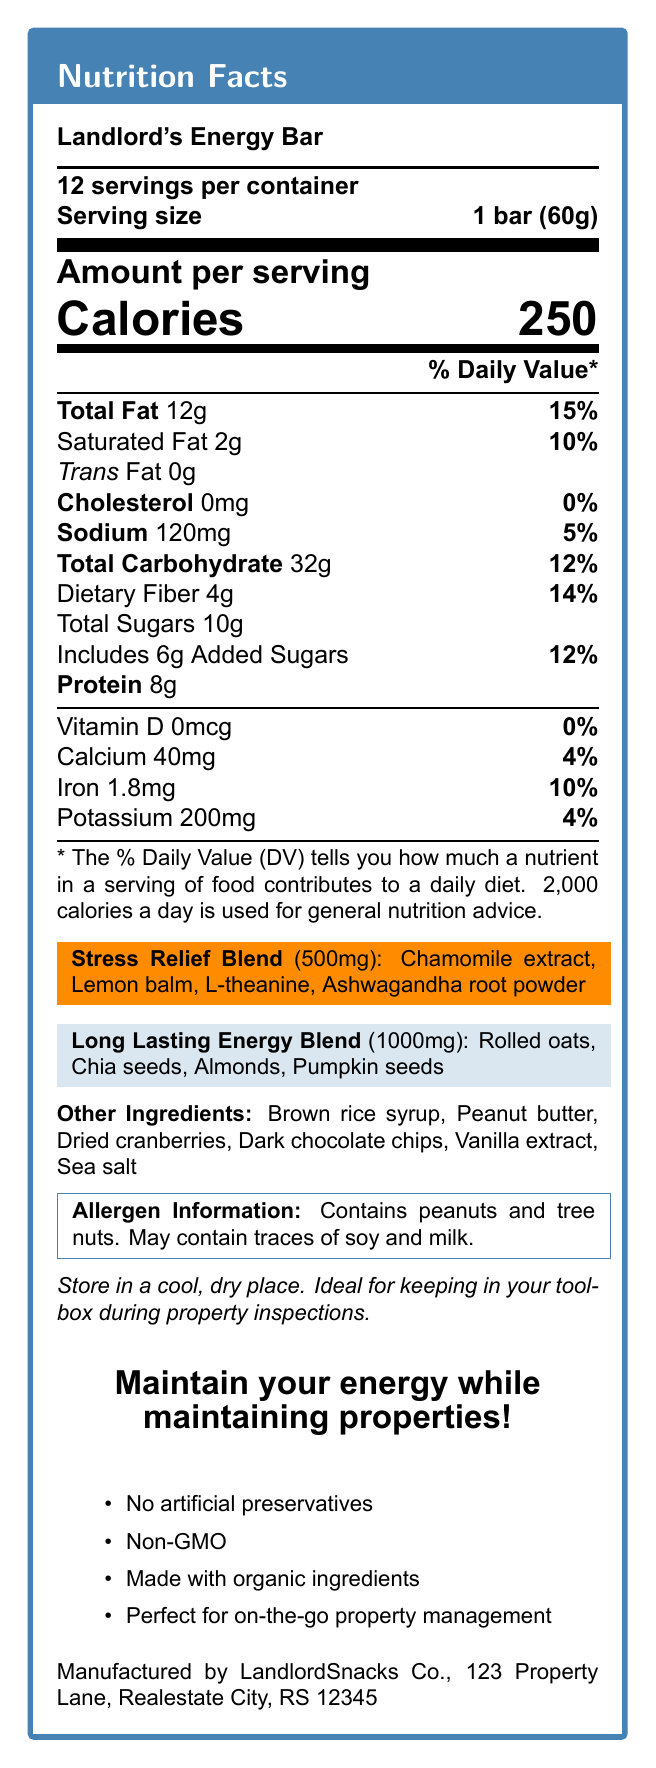1. What is the serving size of the Landlord's Energy Bar? The serving size is clearly indicated in the document as "1 bar (60g)".
Answer: 1 bar (60g) 2. How many grams of total fat are in one serving of this energy bar? The total fat per serving is listed as 12g in the document.
Answer: 12g 3. What is the percentage of daily value for saturated fat in one serving? The document specifies that the daily value for saturated fat is 10%.
Answer: 10% 4. Name two ingredients in the Stress Relief Blend. The Stress Relief Blend section lists the ingredients including Chamomile extract and Lemon balm.
Answer: Chamomile extract, Lemon balm 5. How much protein does one serving of the bar contain? The protein content per bar is stated as 8g in the document.
Answer: 8g 6. What is the sodium content in one serving? A. 0mg B. 120mg C. 200mg D. 40mg The document lists the sodium content in one serving as 120mg.
Answer: B. 120mg 7. Which of the following claims is NOT made by the Landlord's Energy Bar? A. Made with organic ingredients B. Gluten-free C. Non-GMO D. No artificial preservatives The document does not mention the bar being gluten-free, but it does make claims about organic ingredients, being non-GMO, and having no artificial preservatives.
Answer: B. Gluten-free 8. Does the bar contain any cholesterol? The document indicates that there is 0mg of cholesterol, which corresponds to 0%.
Answer: No 9. True or False: This energy bar is ideal for on-the-go property management. The document states, "Perfect for on-the-go property management" under additional claims.
Answer: True 10. Provide a summary of the main information included in the nutrition facts label for the Landlord's Energy Bar. The document provides nutritional information, special ingredient blends, health claims, and allergen details to inform consumers about the content and potential benefits of the bar.
Answer: The Landlord's Energy Bar is a snack designed for maintaining energy while managing properties, featuring a serving size of 1 bar (60g) with 250 calories. It contains 12g of total fat, 32g of carbohydrates, and 8g of protein per serving. The bar includes special blends for stress relief and long-lasting energy. It has claims of being non-GMO, made with organic ingredients, and contains no artificial preservatives. Allergen information indicates the presence of peanuts and tree nuts. 11. How many total calories would you consume if you ate 3 bars? Each bar has 250 calories, so eating 3 bars would result in 250 calories x 3 = 750 calories.
Answer: 750 calories 12. What is the address of the manufacturer? The manufacturer’s address is listed as "LandlordSnacks Co., 123 Property Lane, Realestate City, RS 12345".
Answer: 123 Property Lane, Realestate City, RS 12345 13. How much calcium is in one serving? The document states that each serving contains 40mg of calcium.
Answer: 40mg 14. What is the main idea conveyed in the tagline of the Landlord's Energy Bar? The tagline provides the main idea that the bar helps landlords maintain their energy during property management.
Answer: Maintain your energy while maintaining properties 15. How many milligrams of iron are in a serving? The nutritional information specifies that one serving contains 1.8mg of iron.
Answer: 1.8mg 16. Can you determine the exact recipe or preparation method for the Landlord's Energy Bar? The document provides the ingredient list but does not detail the recipe or preparation method.
Answer: Not enough information 